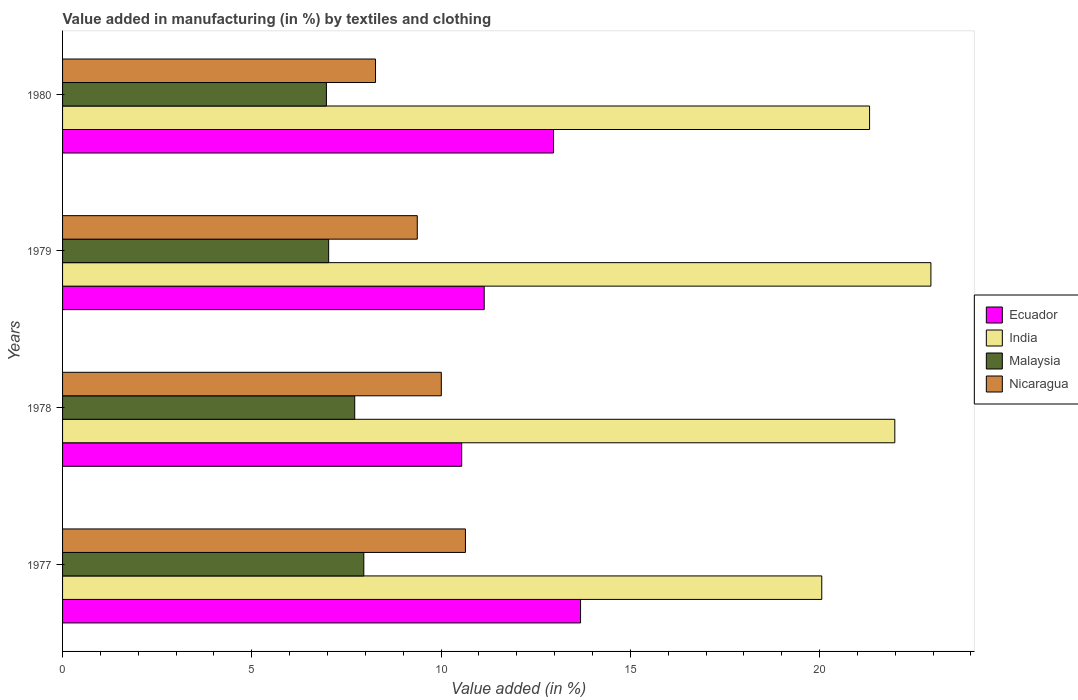Are the number of bars on each tick of the Y-axis equal?
Make the answer very short. Yes. How many bars are there on the 3rd tick from the top?
Ensure brevity in your answer.  4. What is the label of the 3rd group of bars from the top?
Ensure brevity in your answer.  1978. In how many cases, is the number of bars for a given year not equal to the number of legend labels?
Your answer should be compact. 0. What is the percentage of value added in manufacturing by textiles and clothing in India in 1978?
Your answer should be very brief. 21.99. Across all years, what is the maximum percentage of value added in manufacturing by textiles and clothing in Malaysia?
Give a very brief answer. 7.96. Across all years, what is the minimum percentage of value added in manufacturing by textiles and clothing in Ecuador?
Provide a succinct answer. 10.54. In which year was the percentage of value added in manufacturing by textiles and clothing in Nicaragua maximum?
Provide a short and direct response. 1977. In which year was the percentage of value added in manufacturing by textiles and clothing in Ecuador minimum?
Your answer should be very brief. 1978. What is the total percentage of value added in manufacturing by textiles and clothing in Ecuador in the graph?
Offer a terse response. 48.34. What is the difference between the percentage of value added in manufacturing by textiles and clothing in Ecuador in 1979 and that in 1980?
Offer a terse response. -1.83. What is the difference between the percentage of value added in manufacturing by textiles and clothing in Nicaragua in 1980 and the percentage of value added in manufacturing by textiles and clothing in Ecuador in 1977?
Make the answer very short. -5.42. What is the average percentage of value added in manufacturing by textiles and clothing in India per year?
Your answer should be compact. 21.58. In the year 1979, what is the difference between the percentage of value added in manufacturing by textiles and clothing in Malaysia and percentage of value added in manufacturing by textiles and clothing in India?
Offer a very short reply. -15.91. In how many years, is the percentage of value added in manufacturing by textiles and clothing in Malaysia greater than 3 %?
Keep it short and to the point. 4. What is the ratio of the percentage of value added in manufacturing by textiles and clothing in Malaysia in 1978 to that in 1980?
Give a very brief answer. 1.11. Is the difference between the percentage of value added in manufacturing by textiles and clothing in Malaysia in 1979 and 1980 greater than the difference between the percentage of value added in manufacturing by textiles and clothing in India in 1979 and 1980?
Ensure brevity in your answer.  No. What is the difference between the highest and the second highest percentage of value added in manufacturing by textiles and clothing in Malaysia?
Offer a terse response. 0.24. What is the difference between the highest and the lowest percentage of value added in manufacturing by textiles and clothing in India?
Make the answer very short. 2.88. Is it the case that in every year, the sum of the percentage of value added in manufacturing by textiles and clothing in Nicaragua and percentage of value added in manufacturing by textiles and clothing in India is greater than the sum of percentage of value added in manufacturing by textiles and clothing in Malaysia and percentage of value added in manufacturing by textiles and clothing in Ecuador?
Make the answer very short. No. What does the 2nd bar from the top in 1978 represents?
Your answer should be very brief. Malaysia. What does the 2nd bar from the bottom in 1978 represents?
Ensure brevity in your answer.  India. Are all the bars in the graph horizontal?
Ensure brevity in your answer.  Yes. How many years are there in the graph?
Offer a terse response. 4. What is the difference between two consecutive major ticks on the X-axis?
Offer a terse response. 5. Are the values on the major ticks of X-axis written in scientific E-notation?
Offer a terse response. No. Does the graph contain grids?
Provide a succinct answer. No. Where does the legend appear in the graph?
Keep it short and to the point. Center right. How many legend labels are there?
Your answer should be very brief. 4. What is the title of the graph?
Your response must be concise. Value added in manufacturing (in %) by textiles and clothing. Does "World" appear as one of the legend labels in the graph?
Keep it short and to the point. No. What is the label or title of the X-axis?
Give a very brief answer. Value added (in %). What is the Value added (in %) of Ecuador in 1977?
Keep it short and to the point. 13.68. What is the Value added (in %) in India in 1977?
Give a very brief answer. 20.06. What is the Value added (in %) in Malaysia in 1977?
Provide a succinct answer. 7.96. What is the Value added (in %) in Nicaragua in 1977?
Ensure brevity in your answer.  10.64. What is the Value added (in %) of Ecuador in 1978?
Keep it short and to the point. 10.54. What is the Value added (in %) of India in 1978?
Offer a very short reply. 21.99. What is the Value added (in %) of Malaysia in 1978?
Provide a short and direct response. 7.72. What is the Value added (in %) of Nicaragua in 1978?
Provide a short and direct response. 10.01. What is the Value added (in %) in Ecuador in 1979?
Make the answer very short. 11.14. What is the Value added (in %) of India in 1979?
Ensure brevity in your answer.  22.94. What is the Value added (in %) in Malaysia in 1979?
Make the answer very short. 7.03. What is the Value added (in %) in Nicaragua in 1979?
Your response must be concise. 9.37. What is the Value added (in %) in Ecuador in 1980?
Keep it short and to the point. 12.97. What is the Value added (in %) of India in 1980?
Your answer should be compact. 21.32. What is the Value added (in %) in Malaysia in 1980?
Your answer should be very brief. 6.97. What is the Value added (in %) of Nicaragua in 1980?
Your response must be concise. 8.27. Across all years, what is the maximum Value added (in %) in Ecuador?
Keep it short and to the point. 13.68. Across all years, what is the maximum Value added (in %) in India?
Keep it short and to the point. 22.94. Across all years, what is the maximum Value added (in %) of Malaysia?
Keep it short and to the point. 7.96. Across all years, what is the maximum Value added (in %) of Nicaragua?
Offer a very short reply. 10.64. Across all years, what is the minimum Value added (in %) in Ecuador?
Provide a succinct answer. 10.54. Across all years, what is the minimum Value added (in %) of India?
Your answer should be compact. 20.06. Across all years, what is the minimum Value added (in %) in Malaysia?
Ensure brevity in your answer.  6.97. Across all years, what is the minimum Value added (in %) of Nicaragua?
Your answer should be very brief. 8.27. What is the total Value added (in %) of Ecuador in the graph?
Give a very brief answer. 48.34. What is the total Value added (in %) in India in the graph?
Make the answer very short. 86.31. What is the total Value added (in %) of Malaysia in the graph?
Your answer should be very brief. 29.68. What is the total Value added (in %) of Nicaragua in the graph?
Provide a short and direct response. 38.29. What is the difference between the Value added (in %) in Ecuador in 1977 and that in 1978?
Your answer should be compact. 3.14. What is the difference between the Value added (in %) in India in 1977 and that in 1978?
Give a very brief answer. -1.93. What is the difference between the Value added (in %) in Malaysia in 1977 and that in 1978?
Your response must be concise. 0.24. What is the difference between the Value added (in %) of Nicaragua in 1977 and that in 1978?
Give a very brief answer. 0.64. What is the difference between the Value added (in %) in Ecuador in 1977 and that in 1979?
Make the answer very short. 2.55. What is the difference between the Value added (in %) of India in 1977 and that in 1979?
Your answer should be very brief. -2.88. What is the difference between the Value added (in %) in Malaysia in 1977 and that in 1979?
Ensure brevity in your answer.  0.93. What is the difference between the Value added (in %) of Nicaragua in 1977 and that in 1979?
Your answer should be compact. 1.27. What is the difference between the Value added (in %) in Ecuador in 1977 and that in 1980?
Your response must be concise. 0.71. What is the difference between the Value added (in %) of India in 1977 and that in 1980?
Provide a short and direct response. -1.26. What is the difference between the Value added (in %) of Malaysia in 1977 and that in 1980?
Ensure brevity in your answer.  0.99. What is the difference between the Value added (in %) in Nicaragua in 1977 and that in 1980?
Offer a very short reply. 2.38. What is the difference between the Value added (in %) of Ecuador in 1978 and that in 1979?
Your answer should be very brief. -0.59. What is the difference between the Value added (in %) in India in 1978 and that in 1979?
Ensure brevity in your answer.  -0.95. What is the difference between the Value added (in %) of Malaysia in 1978 and that in 1979?
Provide a short and direct response. 0.69. What is the difference between the Value added (in %) in Nicaragua in 1978 and that in 1979?
Provide a short and direct response. 0.64. What is the difference between the Value added (in %) of Ecuador in 1978 and that in 1980?
Provide a short and direct response. -2.43. What is the difference between the Value added (in %) in India in 1978 and that in 1980?
Give a very brief answer. 0.67. What is the difference between the Value added (in %) of Malaysia in 1978 and that in 1980?
Offer a terse response. 0.75. What is the difference between the Value added (in %) in Nicaragua in 1978 and that in 1980?
Make the answer very short. 1.74. What is the difference between the Value added (in %) in Ecuador in 1979 and that in 1980?
Offer a very short reply. -1.83. What is the difference between the Value added (in %) in India in 1979 and that in 1980?
Your answer should be compact. 1.62. What is the difference between the Value added (in %) of Malaysia in 1979 and that in 1980?
Provide a succinct answer. 0.06. What is the difference between the Value added (in %) of Nicaragua in 1979 and that in 1980?
Your answer should be compact. 1.1. What is the difference between the Value added (in %) in Ecuador in 1977 and the Value added (in %) in India in 1978?
Provide a short and direct response. -8.3. What is the difference between the Value added (in %) in Ecuador in 1977 and the Value added (in %) in Malaysia in 1978?
Make the answer very short. 5.97. What is the difference between the Value added (in %) in Ecuador in 1977 and the Value added (in %) in Nicaragua in 1978?
Provide a short and direct response. 3.68. What is the difference between the Value added (in %) in India in 1977 and the Value added (in %) in Malaysia in 1978?
Provide a short and direct response. 12.34. What is the difference between the Value added (in %) of India in 1977 and the Value added (in %) of Nicaragua in 1978?
Keep it short and to the point. 10.05. What is the difference between the Value added (in %) of Malaysia in 1977 and the Value added (in %) of Nicaragua in 1978?
Provide a succinct answer. -2.05. What is the difference between the Value added (in %) of Ecuador in 1977 and the Value added (in %) of India in 1979?
Provide a succinct answer. -9.26. What is the difference between the Value added (in %) in Ecuador in 1977 and the Value added (in %) in Malaysia in 1979?
Make the answer very short. 6.66. What is the difference between the Value added (in %) of Ecuador in 1977 and the Value added (in %) of Nicaragua in 1979?
Keep it short and to the point. 4.31. What is the difference between the Value added (in %) of India in 1977 and the Value added (in %) of Malaysia in 1979?
Your answer should be compact. 13.03. What is the difference between the Value added (in %) in India in 1977 and the Value added (in %) in Nicaragua in 1979?
Make the answer very short. 10.69. What is the difference between the Value added (in %) of Malaysia in 1977 and the Value added (in %) of Nicaragua in 1979?
Ensure brevity in your answer.  -1.41. What is the difference between the Value added (in %) in Ecuador in 1977 and the Value added (in %) in India in 1980?
Offer a terse response. -7.64. What is the difference between the Value added (in %) in Ecuador in 1977 and the Value added (in %) in Malaysia in 1980?
Ensure brevity in your answer.  6.71. What is the difference between the Value added (in %) in Ecuador in 1977 and the Value added (in %) in Nicaragua in 1980?
Provide a short and direct response. 5.42. What is the difference between the Value added (in %) of India in 1977 and the Value added (in %) of Malaysia in 1980?
Offer a very short reply. 13.09. What is the difference between the Value added (in %) in India in 1977 and the Value added (in %) in Nicaragua in 1980?
Your response must be concise. 11.79. What is the difference between the Value added (in %) in Malaysia in 1977 and the Value added (in %) in Nicaragua in 1980?
Your response must be concise. -0.31. What is the difference between the Value added (in %) of Ecuador in 1978 and the Value added (in %) of India in 1979?
Provide a succinct answer. -12.4. What is the difference between the Value added (in %) in Ecuador in 1978 and the Value added (in %) in Malaysia in 1979?
Offer a very short reply. 3.51. What is the difference between the Value added (in %) of Ecuador in 1978 and the Value added (in %) of Nicaragua in 1979?
Offer a terse response. 1.17. What is the difference between the Value added (in %) in India in 1978 and the Value added (in %) in Malaysia in 1979?
Provide a succinct answer. 14.96. What is the difference between the Value added (in %) in India in 1978 and the Value added (in %) in Nicaragua in 1979?
Provide a succinct answer. 12.62. What is the difference between the Value added (in %) of Malaysia in 1978 and the Value added (in %) of Nicaragua in 1979?
Keep it short and to the point. -1.65. What is the difference between the Value added (in %) in Ecuador in 1978 and the Value added (in %) in India in 1980?
Keep it short and to the point. -10.78. What is the difference between the Value added (in %) in Ecuador in 1978 and the Value added (in %) in Malaysia in 1980?
Keep it short and to the point. 3.57. What is the difference between the Value added (in %) of Ecuador in 1978 and the Value added (in %) of Nicaragua in 1980?
Your answer should be compact. 2.28. What is the difference between the Value added (in %) in India in 1978 and the Value added (in %) in Malaysia in 1980?
Provide a short and direct response. 15.02. What is the difference between the Value added (in %) in India in 1978 and the Value added (in %) in Nicaragua in 1980?
Give a very brief answer. 13.72. What is the difference between the Value added (in %) of Malaysia in 1978 and the Value added (in %) of Nicaragua in 1980?
Offer a very short reply. -0.55. What is the difference between the Value added (in %) of Ecuador in 1979 and the Value added (in %) of India in 1980?
Keep it short and to the point. -10.18. What is the difference between the Value added (in %) in Ecuador in 1979 and the Value added (in %) in Malaysia in 1980?
Give a very brief answer. 4.17. What is the difference between the Value added (in %) in Ecuador in 1979 and the Value added (in %) in Nicaragua in 1980?
Keep it short and to the point. 2.87. What is the difference between the Value added (in %) of India in 1979 and the Value added (in %) of Malaysia in 1980?
Provide a succinct answer. 15.97. What is the difference between the Value added (in %) of India in 1979 and the Value added (in %) of Nicaragua in 1980?
Provide a succinct answer. 14.67. What is the difference between the Value added (in %) of Malaysia in 1979 and the Value added (in %) of Nicaragua in 1980?
Give a very brief answer. -1.24. What is the average Value added (in %) in Ecuador per year?
Your response must be concise. 12.09. What is the average Value added (in %) of India per year?
Give a very brief answer. 21.58. What is the average Value added (in %) in Malaysia per year?
Your response must be concise. 7.42. What is the average Value added (in %) in Nicaragua per year?
Keep it short and to the point. 9.57. In the year 1977, what is the difference between the Value added (in %) of Ecuador and Value added (in %) of India?
Provide a short and direct response. -6.37. In the year 1977, what is the difference between the Value added (in %) in Ecuador and Value added (in %) in Malaysia?
Your answer should be compact. 5.73. In the year 1977, what is the difference between the Value added (in %) in Ecuador and Value added (in %) in Nicaragua?
Keep it short and to the point. 3.04. In the year 1977, what is the difference between the Value added (in %) in India and Value added (in %) in Malaysia?
Provide a succinct answer. 12.1. In the year 1977, what is the difference between the Value added (in %) in India and Value added (in %) in Nicaragua?
Keep it short and to the point. 9.41. In the year 1977, what is the difference between the Value added (in %) of Malaysia and Value added (in %) of Nicaragua?
Make the answer very short. -2.69. In the year 1978, what is the difference between the Value added (in %) in Ecuador and Value added (in %) in India?
Offer a very short reply. -11.44. In the year 1978, what is the difference between the Value added (in %) in Ecuador and Value added (in %) in Malaysia?
Offer a terse response. 2.83. In the year 1978, what is the difference between the Value added (in %) in Ecuador and Value added (in %) in Nicaragua?
Offer a terse response. 0.54. In the year 1978, what is the difference between the Value added (in %) of India and Value added (in %) of Malaysia?
Give a very brief answer. 14.27. In the year 1978, what is the difference between the Value added (in %) of India and Value added (in %) of Nicaragua?
Your answer should be very brief. 11.98. In the year 1978, what is the difference between the Value added (in %) of Malaysia and Value added (in %) of Nicaragua?
Provide a short and direct response. -2.29. In the year 1979, what is the difference between the Value added (in %) of Ecuador and Value added (in %) of India?
Your answer should be very brief. -11.8. In the year 1979, what is the difference between the Value added (in %) of Ecuador and Value added (in %) of Malaysia?
Ensure brevity in your answer.  4.11. In the year 1979, what is the difference between the Value added (in %) in Ecuador and Value added (in %) in Nicaragua?
Ensure brevity in your answer.  1.77. In the year 1979, what is the difference between the Value added (in %) of India and Value added (in %) of Malaysia?
Your answer should be compact. 15.91. In the year 1979, what is the difference between the Value added (in %) in India and Value added (in %) in Nicaragua?
Give a very brief answer. 13.57. In the year 1979, what is the difference between the Value added (in %) of Malaysia and Value added (in %) of Nicaragua?
Offer a terse response. -2.34. In the year 1980, what is the difference between the Value added (in %) of Ecuador and Value added (in %) of India?
Provide a succinct answer. -8.35. In the year 1980, what is the difference between the Value added (in %) of Ecuador and Value added (in %) of Malaysia?
Provide a succinct answer. 6. In the year 1980, what is the difference between the Value added (in %) of Ecuador and Value added (in %) of Nicaragua?
Your response must be concise. 4.7. In the year 1980, what is the difference between the Value added (in %) of India and Value added (in %) of Malaysia?
Give a very brief answer. 14.35. In the year 1980, what is the difference between the Value added (in %) in India and Value added (in %) in Nicaragua?
Offer a terse response. 13.05. In the year 1980, what is the difference between the Value added (in %) in Malaysia and Value added (in %) in Nicaragua?
Provide a succinct answer. -1.3. What is the ratio of the Value added (in %) of Ecuador in 1977 to that in 1978?
Offer a terse response. 1.3. What is the ratio of the Value added (in %) of India in 1977 to that in 1978?
Ensure brevity in your answer.  0.91. What is the ratio of the Value added (in %) of Malaysia in 1977 to that in 1978?
Offer a very short reply. 1.03. What is the ratio of the Value added (in %) of Nicaragua in 1977 to that in 1978?
Offer a very short reply. 1.06. What is the ratio of the Value added (in %) in Ecuador in 1977 to that in 1979?
Offer a terse response. 1.23. What is the ratio of the Value added (in %) in India in 1977 to that in 1979?
Your answer should be compact. 0.87. What is the ratio of the Value added (in %) of Malaysia in 1977 to that in 1979?
Offer a very short reply. 1.13. What is the ratio of the Value added (in %) in Nicaragua in 1977 to that in 1979?
Make the answer very short. 1.14. What is the ratio of the Value added (in %) of Ecuador in 1977 to that in 1980?
Provide a short and direct response. 1.06. What is the ratio of the Value added (in %) in India in 1977 to that in 1980?
Provide a short and direct response. 0.94. What is the ratio of the Value added (in %) in Malaysia in 1977 to that in 1980?
Offer a very short reply. 1.14. What is the ratio of the Value added (in %) of Nicaragua in 1977 to that in 1980?
Ensure brevity in your answer.  1.29. What is the ratio of the Value added (in %) of Ecuador in 1978 to that in 1979?
Make the answer very short. 0.95. What is the ratio of the Value added (in %) in India in 1978 to that in 1979?
Ensure brevity in your answer.  0.96. What is the ratio of the Value added (in %) of Malaysia in 1978 to that in 1979?
Your answer should be compact. 1.1. What is the ratio of the Value added (in %) in Nicaragua in 1978 to that in 1979?
Ensure brevity in your answer.  1.07. What is the ratio of the Value added (in %) of Ecuador in 1978 to that in 1980?
Give a very brief answer. 0.81. What is the ratio of the Value added (in %) of India in 1978 to that in 1980?
Give a very brief answer. 1.03. What is the ratio of the Value added (in %) in Malaysia in 1978 to that in 1980?
Give a very brief answer. 1.11. What is the ratio of the Value added (in %) in Nicaragua in 1978 to that in 1980?
Your response must be concise. 1.21. What is the ratio of the Value added (in %) of Ecuador in 1979 to that in 1980?
Keep it short and to the point. 0.86. What is the ratio of the Value added (in %) in India in 1979 to that in 1980?
Ensure brevity in your answer.  1.08. What is the ratio of the Value added (in %) of Malaysia in 1979 to that in 1980?
Make the answer very short. 1.01. What is the ratio of the Value added (in %) of Nicaragua in 1979 to that in 1980?
Provide a short and direct response. 1.13. What is the difference between the highest and the second highest Value added (in %) of Ecuador?
Offer a very short reply. 0.71. What is the difference between the highest and the second highest Value added (in %) of India?
Give a very brief answer. 0.95. What is the difference between the highest and the second highest Value added (in %) of Malaysia?
Make the answer very short. 0.24. What is the difference between the highest and the second highest Value added (in %) in Nicaragua?
Keep it short and to the point. 0.64. What is the difference between the highest and the lowest Value added (in %) of Ecuador?
Make the answer very short. 3.14. What is the difference between the highest and the lowest Value added (in %) in India?
Offer a terse response. 2.88. What is the difference between the highest and the lowest Value added (in %) of Nicaragua?
Keep it short and to the point. 2.38. 